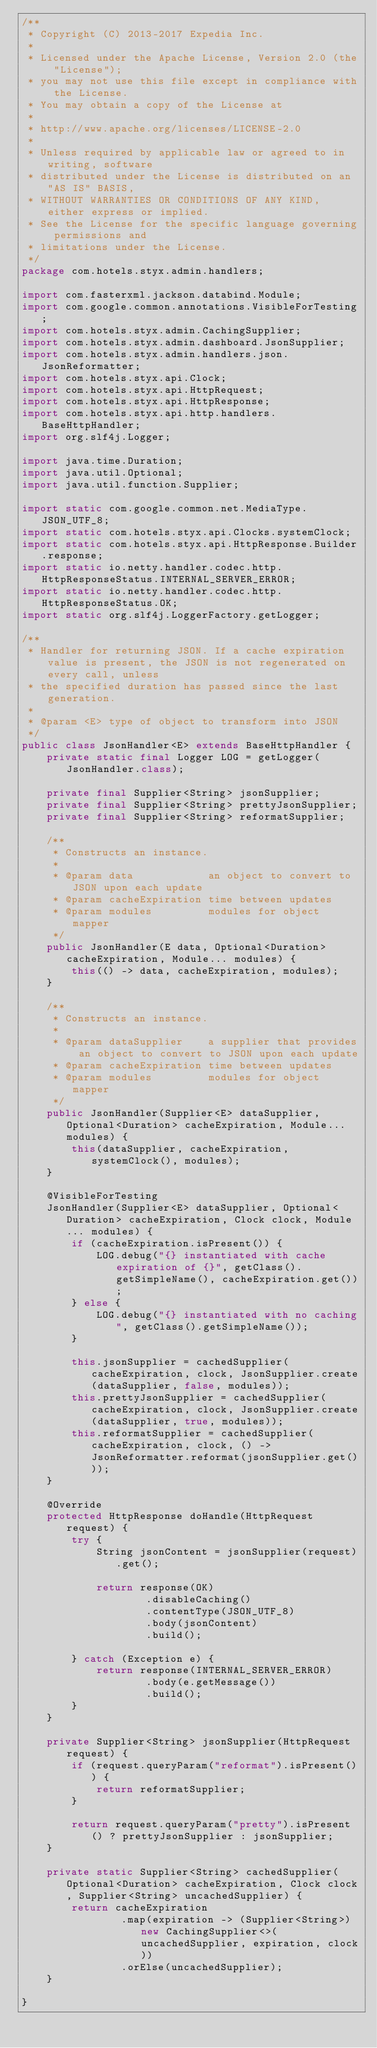Convert code to text. <code><loc_0><loc_0><loc_500><loc_500><_Java_>/**
 * Copyright (C) 2013-2017 Expedia Inc.
 *
 * Licensed under the Apache License, Version 2.0 (the "License");
 * you may not use this file except in compliance with the License.
 * You may obtain a copy of the License at
 *
 * http://www.apache.org/licenses/LICENSE-2.0
 *
 * Unless required by applicable law or agreed to in writing, software
 * distributed under the License is distributed on an "AS IS" BASIS,
 * WITHOUT WARRANTIES OR CONDITIONS OF ANY KIND, either express or implied.
 * See the License for the specific language governing permissions and
 * limitations under the License.
 */
package com.hotels.styx.admin.handlers;

import com.fasterxml.jackson.databind.Module;
import com.google.common.annotations.VisibleForTesting;
import com.hotels.styx.admin.CachingSupplier;
import com.hotels.styx.admin.dashboard.JsonSupplier;
import com.hotels.styx.admin.handlers.json.JsonReformatter;
import com.hotels.styx.api.Clock;
import com.hotels.styx.api.HttpRequest;
import com.hotels.styx.api.HttpResponse;
import com.hotels.styx.api.http.handlers.BaseHttpHandler;
import org.slf4j.Logger;

import java.time.Duration;
import java.util.Optional;
import java.util.function.Supplier;

import static com.google.common.net.MediaType.JSON_UTF_8;
import static com.hotels.styx.api.Clocks.systemClock;
import static com.hotels.styx.api.HttpResponse.Builder.response;
import static io.netty.handler.codec.http.HttpResponseStatus.INTERNAL_SERVER_ERROR;
import static io.netty.handler.codec.http.HttpResponseStatus.OK;
import static org.slf4j.LoggerFactory.getLogger;

/**
 * Handler for returning JSON. If a cache expiration value is present, the JSON is not regenerated on every call, unless
 * the specified duration has passed since the last generation.
 *
 * @param <E> type of object to transform into JSON
 */
public class JsonHandler<E> extends BaseHttpHandler {
    private static final Logger LOG = getLogger(JsonHandler.class);

    private final Supplier<String> jsonSupplier;
    private final Supplier<String> prettyJsonSupplier;
    private final Supplier<String> reformatSupplier;

    /**
     * Constructs an instance.
     *
     * @param data            an object to convert to JSON upon each update
     * @param cacheExpiration time between updates
     * @param modules         modules for object mapper
     */
    public JsonHandler(E data, Optional<Duration> cacheExpiration, Module... modules) {
        this(() -> data, cacheExpiration, modules);
    }

    /**
     * Constructs an instance.
     *
     * @param dataSupplier    a supplier that provides an object to convert to JSON upon each update
     * @param cacheExpiration time between updates
     * @param modules         modules for object mapper
     */
    public JsonHandler(Supplier<E> dataSupplier, Optional<Duration> cacheExpiration, Module... modules) {
        this(dataSupplier, cacheExpiration, systemClock(), modules);
    }

    @VisibleForTesting
    JsonHandler(Supplier<E> dataSupplier, Optional<Duration> cacheExpiration, Clock clock, Module... modules) {
        if (cacheExpiration.isPresent()) {
            LOG.debug("{} instantiated with cache expiration of {}", getClass().getSimpleName(), cacheExpiration.get());
        } else {
            LOG.debug("{} instantiated with no caching", getClass().getSimpleName());
        }

        this.jsonSupplier = cachedSupplier(cacheExpiration, clock, JsonSupplier.create(dataSupplier, false, modules));
        this.prettyJsonSupplier = cachedSupplier(cacheExpiration, clock, JsonSupplier.create(dataSupplier, true, modules));
        this.reformatSupplier = cachedSupplier(cacheExpiration, clock, () -> JsonReformatter.reformat(jsonSupplier.get()));
    }

    @Override
    protected HttpResponse doHandle(HttpRequest request) {
        try {
            String jsonContent = jsonSupplier(request).get();

            return response(OK)
                    .disableCaching()
                    .contentType(JSON_UTF_8)
                    .body(jsonContent)
                    .build();

        } catch (Exception e) {
            return response(INTERNAL_SERVER_ERROR)
                    .body(e.getMessage())
                    .build();
        }
    }

    private Supplier<String> jsonSupplier(HttpRequest request) {
        if (request.queryParam("reformat").isPresent()) {
            return reformatSupplier;
        }

        return request.queryParam("pretty").isPresent() ? prettyJsonSupplier : jsonSupplier;
    }

    private static Supplier<String> cachedSupplier(Optional<Duration> cacheExpiration, Clock clock, Supplier<String> uncachedSupplier) {
        return cacheExpiration
                .map(expiration -> (Supplier<String>) new CachingSupplier<>(uncachedSupplier, expiration, clock))
                .orElse(uncachedSupplier);
    }

}
</code> 